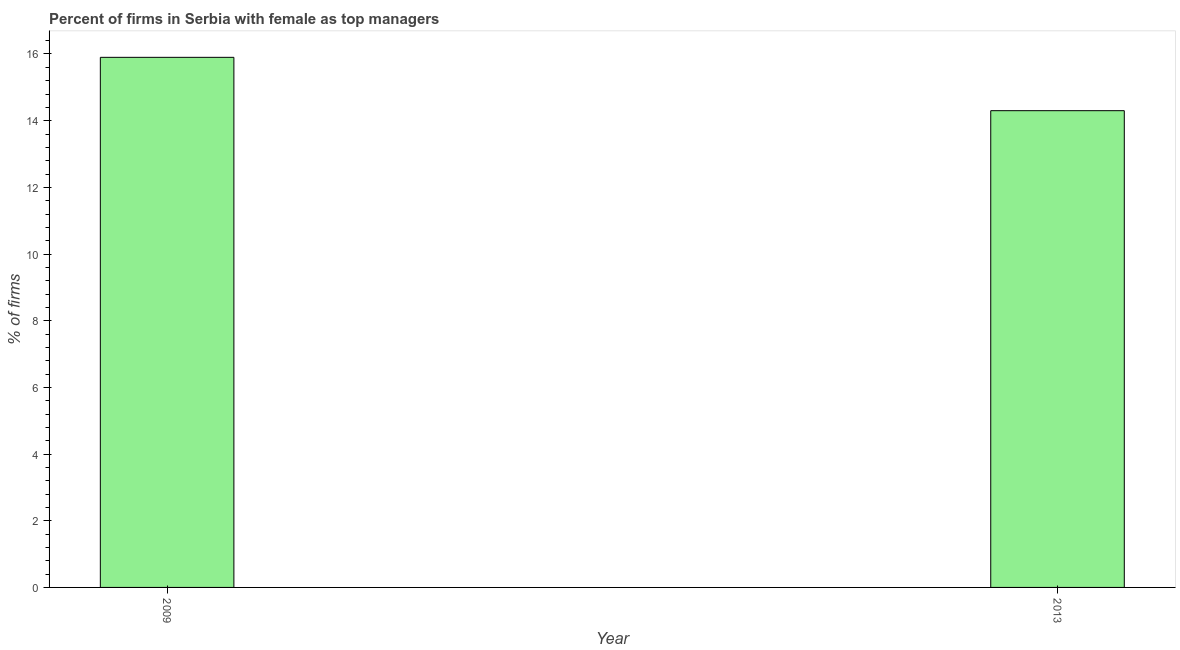Does the graph contain grids?
Your answer should be compact. No. What is the title of the graph?
Provide a succinct answer. Percent of firms in Serbia with female as top managers. What is the label or title of the X-axis?
Your answer should be compact. Year. What is the label or title of the Y-axis?
Provide a short and direct response. % of firms. Across all years, what is the maximum percentage of firms with female as top manager?
Keep it short and to the point. 15.9. What is the sum of the percentage of firms with female as top manager?
Provide a succinct answer. 30.2. What is the average percentage of firms with female as top manager per year?
Your answer should be very brief. 15.1. What is the median percentage of firms with female as top manager?
Offer a very short reply. 15.1. Do a majority of the years between 2009 and 2013 (inclusive) have percentage of firms with female as top manager greater than 7.2 %?
Your answer should be compact. Yes. What is the ratio of the percentage of firms with female as top manager in 2009 to that in 2013?
Ensure brevity in your answer.  1.11. In how many years, is the percentage of firms with female as top manager greater than the average percentage of firms with female as top manager taken over all years?
Your response must be concise. 1. How many bars are there?
Your response must be concise. 2. What is the difference between two consecutive major ticks on the Y-axis?
Provide a short and direct response. 2. What is the % of firms of 2009?
Ensure brevity in your answer.  15.9. What is the % of firms in 2013?
Your answer should be compact. 14.3. What is the ratio of the % of firms in 2009 to that in 2013?
Give a very brief answer. 1.11. 